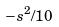Convert formula to latex. <formula><loc_0><loc_0><loc_500><loc_500>- s ^ { 2 } / 1 0</formula> 